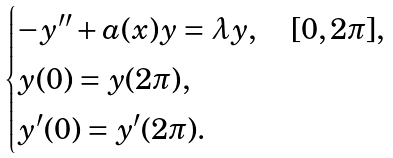Convert formula to latex. <formula><loc_0><loc_0><loc_500><loc_500>\begin{cases} - y ^ { \prime \prime } + a ( x ) y = \lambda y , \quad [ 0 , 2 \pi ] , \\ y ( 0 ) = y ( 2 \pi ) , \\ y ^ { \prime } ( 0 ) = y ^ { \prime } ( 2 \pi ) . \end{cases}</formula> 